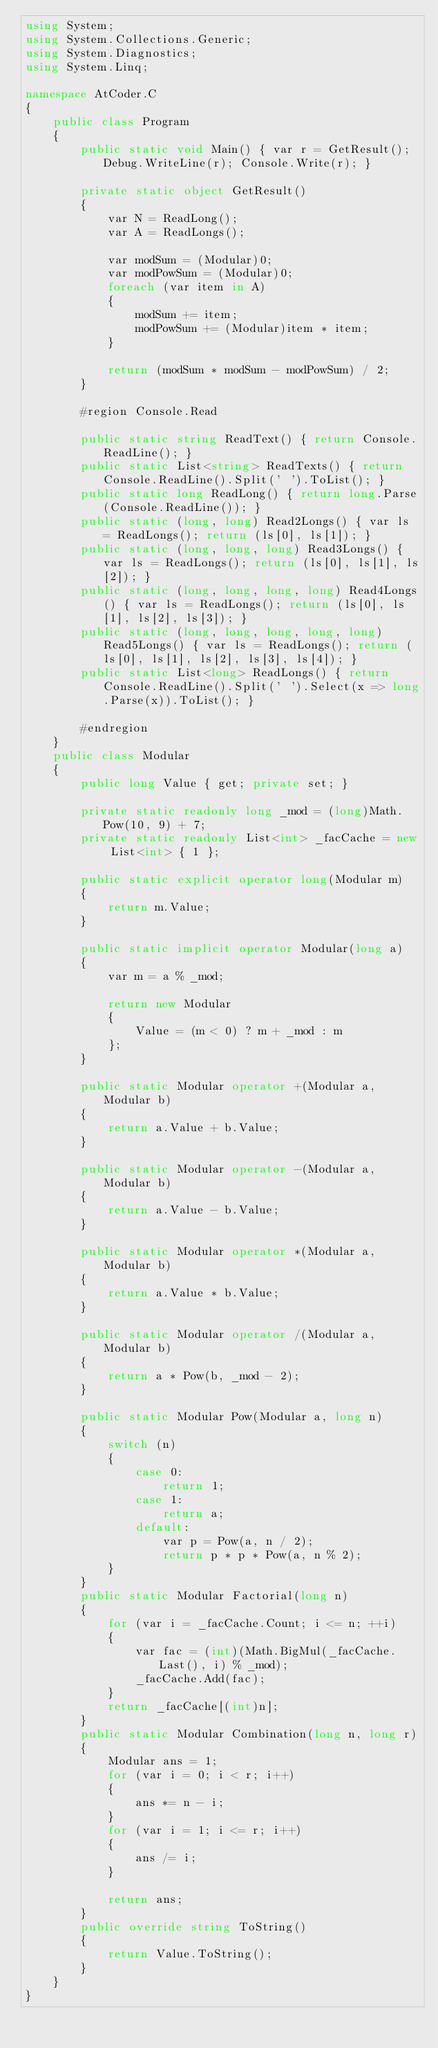<code> <loc_0><loc_0><loc_500><loc_500><_C#_>using System;
using System.Collections.Generic;
using System.Diagnostics;
using System.Linq;

namespace AtCoder.C
{
    public class Program
    {
        public static void Main() { var r = GetResult(); Debug.WriteLine(r); Console.Write(r); }

        private static object GetResult()
        {
            var N = ReadLong();
            var A = ReadLongs();

            var modSum = (Modular)0;
            var modPowSum = (Modular)0;
            foreach (var item in A)
            {
                modSum += item;
                modPowSum += (Modular)item * item;
            }

            return (modSum * modSum - modPowSum) / 2;
        }

        #region Console.Read

        public static string ReadText() { return Console.ReadLine(); }
        public static List<string> ReadTexts() { return Console.ReadLine().Split(' ').ToList(); }
        public static long ReadLong() { return long.Parse(Console.ReadLine()); }
        public static (long, long) Read2Longs() { var ls = ReadLongs(); return (ls[0], ls[1]); }
        public static (long, long, long) Read3Longs() { var ls = ReadLongs(); return (ls[0], ls[1], ls[2]); }
        public static (long, long, long, long) Read4Longs() { var ls = ReadLongs(); return (ls[0], ls[1], ls[2], ls[3]); }
        public static (long, long, long, long, long) Read5Longs() { var ls = ReadLongs(); return (ls[0], ls[1], ls[2], ls[3], ls[4]); }
        public static List<long> ReadLongs() { return Console.ReadLine().Split(' ').Select(x => long.Parse(x)).ToList(); }

        #endregion
    }
    public class Modular
    {
        public long Value { get; private set; }

        private static readonly long _mod = (long)Math.Pow(10, 9) + 7;
        private static readonly List<int> _facCache = new List<int> { 1 };

        public static explicit operator long(Modular m)
        {
            return m.Value;
        }

        public static implicit operator Modular(long a)
        {
            var m = a % _mod;

            return new Modular
            {
                Value = (m < 0) ? m + _mod : m
            };
        }

        public static Modular operator +(Modular a, Modular b)
        {
            return a.Value + b.Value;
        }

        public static Modular operator -(Modular a, Modular b)
        {
            return a.Value - b.Value;
        }

        public static Modular operator *(Modular a, Modular b)
        {
            return a.Value * b.Value;
        }

        public static Modular operator /(Modular a, Modular b)
        {
            return a * Pow(b, _mod - 2);
        }

        public static Modular Pow(Modular a, long n)
        {
            switch (n)
            {
                case 0:
                    return 1;
                case 1:
                    return a;
                default:
                    var p = Pow(a, n / 2);
                    return p * p * Pow(a, n % 2);
            }
        }
        public static Modular Factorial(long n)
        {
            for (var i = _facCache.Count; i <= n; ++i)
            {
                var fac = (int)(Math.BigMul(_facCache.Last(), i) % _mod);
                _facCache.Add(fac);
            }
            return _facCache[(int)n];
        }
        public static Modular Combination(long n, long r)
        {
            Modular ans = 1;
            for (var i = 0; i < r; i++)
            {
                ans *= n - i;
            }
            for (var i = 1; i <= r; i++)
            {
                ans /= i;
            }

            return ans;
        }
        public override string ToString()
        {
            return Value.ToString();
        }
    }
}
</code> 